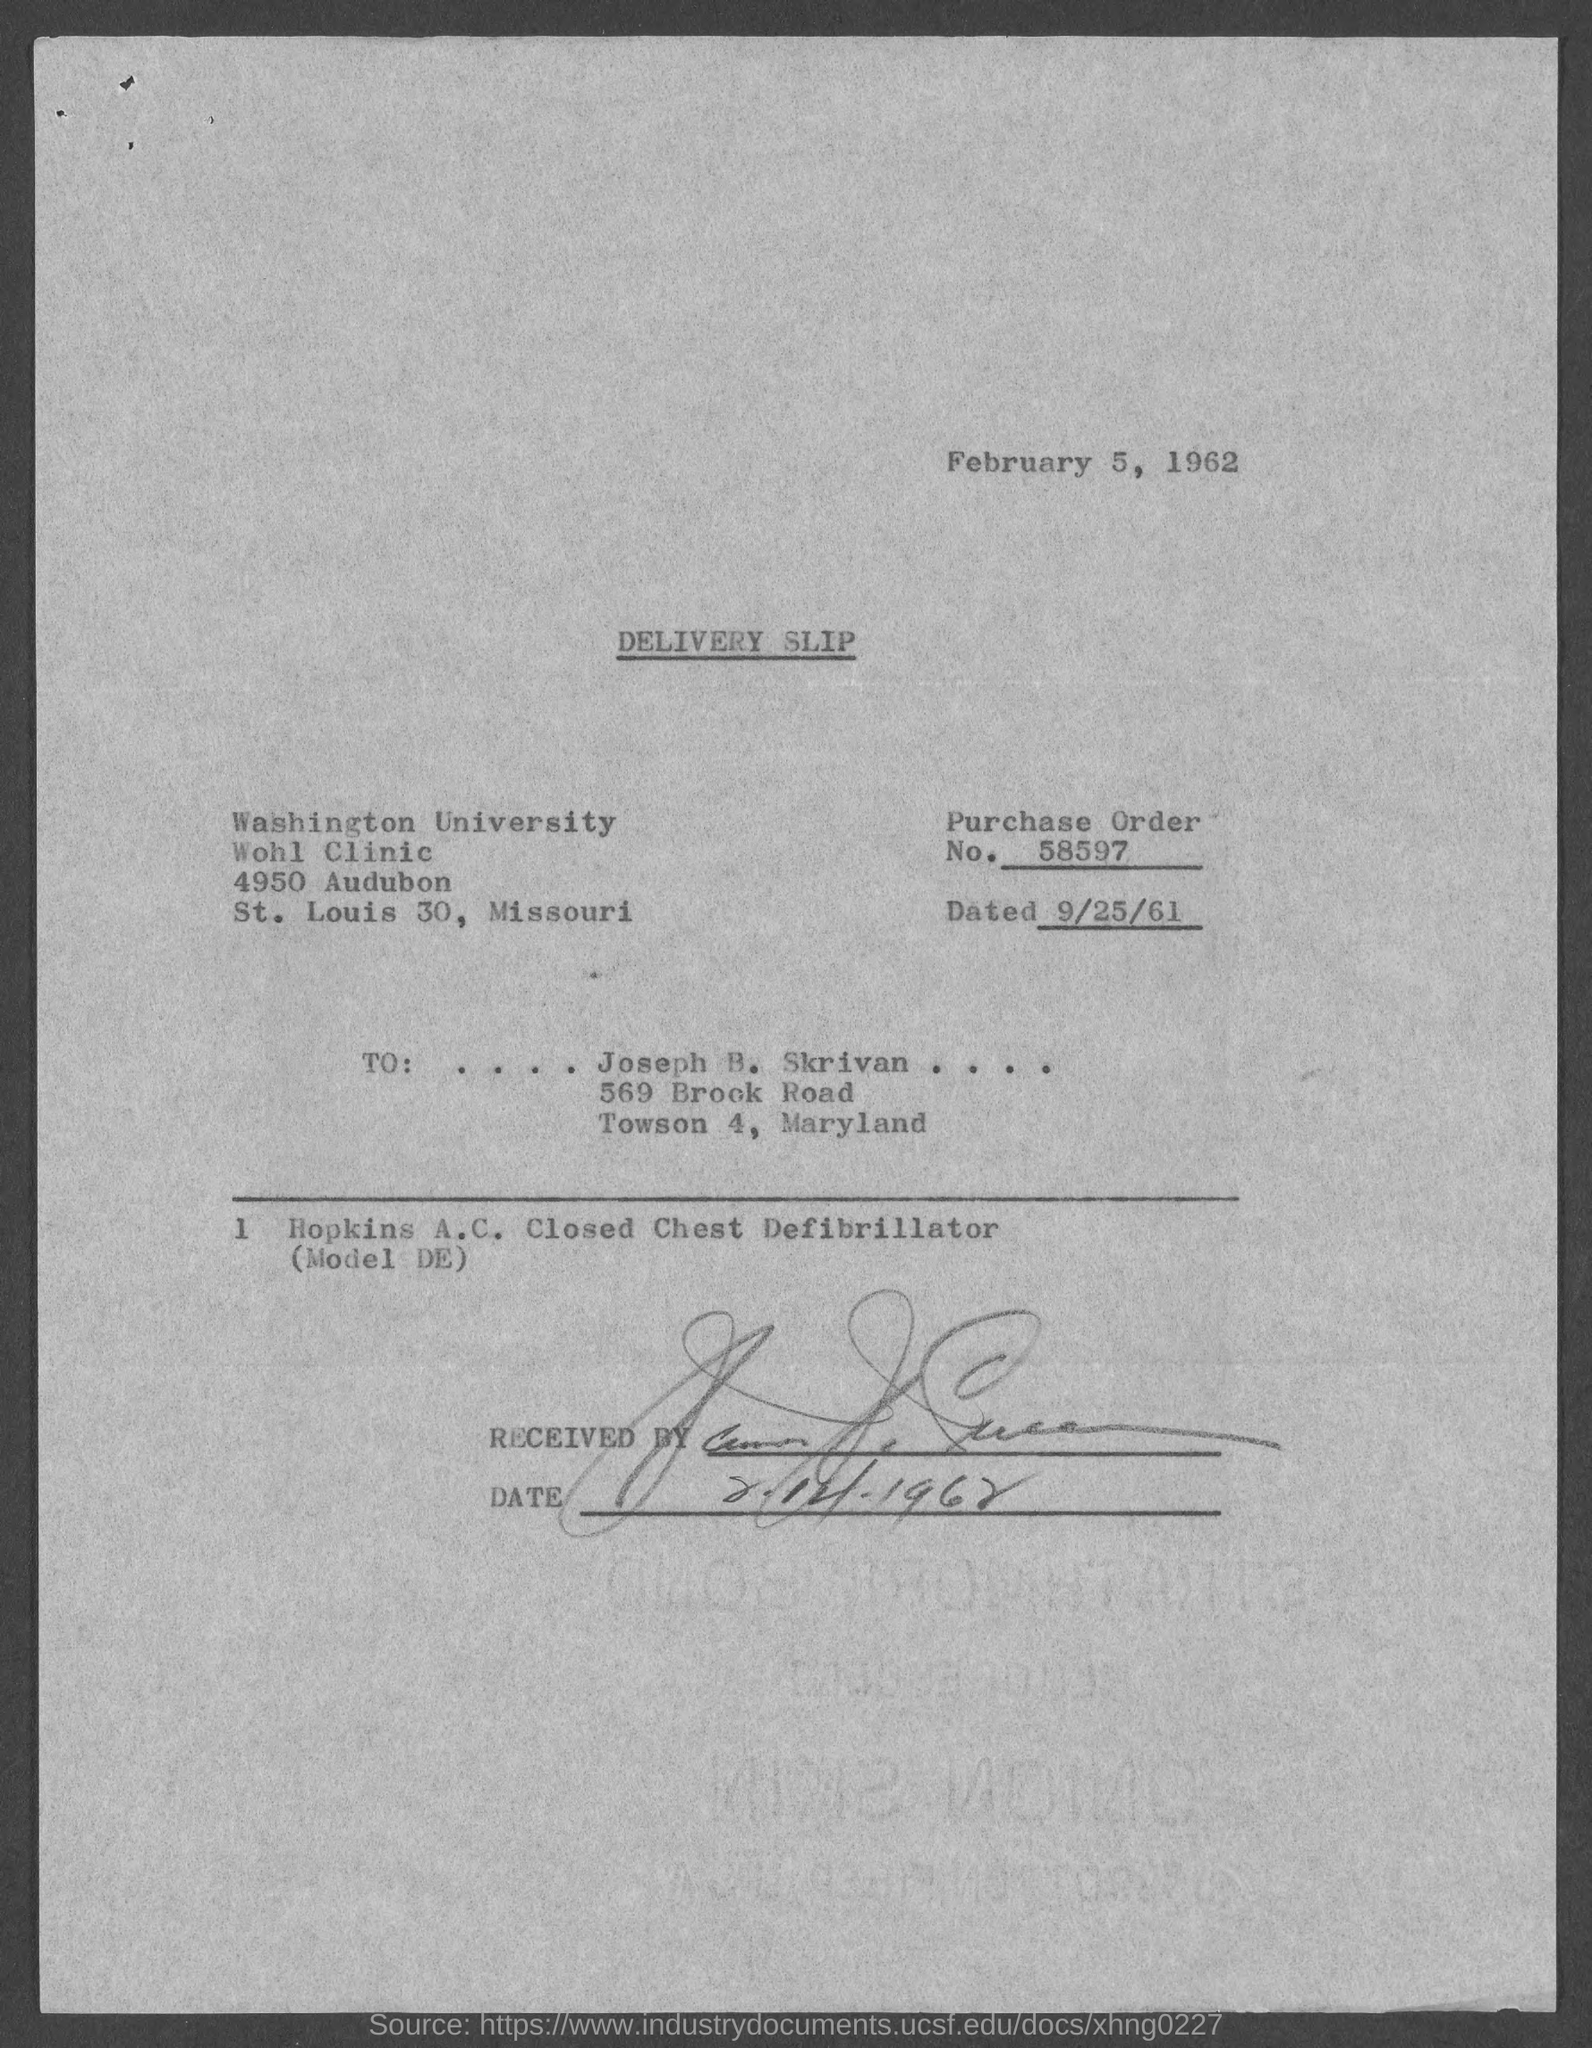What is the date on top of the document?
Your answer should be compact. February 5, 1962. What is heading of the document?
Ensure brevity in your answer.  Delivery Slip. What is the purchase order number?
Give a very brief answer. 58597. 